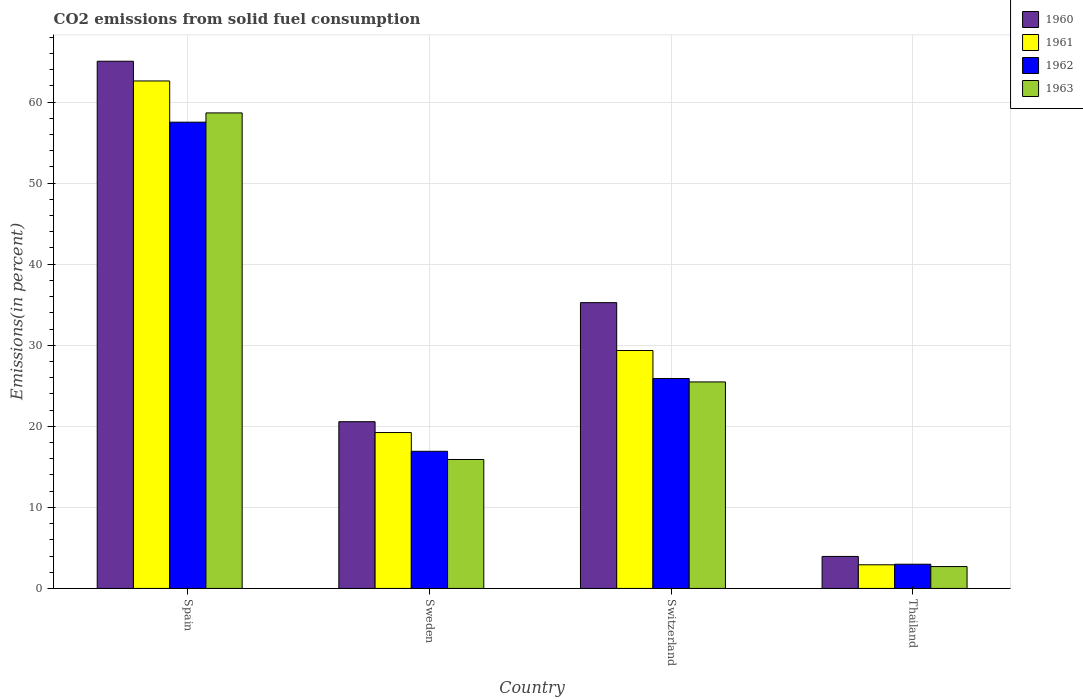How many groups of bars are there?
Provide a succinct answer. 4. How many bars are there on the 1st tick from the left?
Ensure brevity in your answer.  4. How many bars are there on the 3rd tick from the right?
Offer a very short reply. 4. What is the label of the 2nd group of bars from the left?
Keep it short and to the point. Sweden. In how many cases, is the number of bars for a given country not equal to the number of legend labels?
Your answer should be compact. 0. What is the total CO2 emitted in 1963 in Sweden?
Offer a very short reply. 15.91. Across all countries, what is the maximum total CO2 emitted in 1963?
Make the answer very short. 58.66. Across all countries, what is the minimum total CO2 emitted in 1961?
Your answer should be very brief. 2.92. In which country was the total CO2 emitted in 1961 maximum?
Your answer should be very brief. Spain. In which country was the total CO2 emitted in 1960 minimum?
Keep it short and to the point. Thailand. What is the total total CO2 emitted in 1960 in the graph?
Your answer should be very brief. 124.81. What is the difference between the total CO2 emitted in 1962 in Sweden and that in Switzerland?
Keep it short and to the point. -8.98. What is the difference between the total CO2 emitted in 1960 in Switzerland and the total CO2 emitted in 1961 in Thailand?
Give a very brief answer. 32.34. What is the average total CO2 emitted in 1963 per country?
Your answer should be compact. 25.69. What is the difference between the total CO2 emitted of/in 1960 and total CO2 emitted of/in 1963 in Sweden?
Give a very brief answer. 4.66. In how many countries, is the total CO2 emitted in 1962 greater than 34 %?
Your response must be concise. 1. What is the ratio of the total CO2 emitted in 1961 in Sweden to that in Thailand?
Offer a very short reply. 6.59. What is the difference between the highest and the second highest total CO2 emitted in 1960?
Give a very brief answer. 29.78. What is the difference between the highest and the lowest total CO2 emitted in 1960?
Offer a terse response. 61.09. Is it the case that in every country, the sum of the total CO2 emitted in 1961 and total CO2 emitted in 1963 is greater than the total CO2 emitted in 1962?
Provide a short and direct response. Yes. How many bars are there?
Make the answer very short. 16. Are the values on the major ticks of Y-axis written in scientific E-notation?
Your answer should be compact. No. Does the graph contain grids?
Ensure brevity in your answer.  Yes. Where does the legend appear in the graph?
Your answer should be very brief. Top right. How many legend labels are there?
Offer a terse response. 4. How are the legend labels stacked?
Your response must be concise. Vertical. What is the title of the graph?
Your answer should be compact. CO2 emissions from solid fuel consumption. Does "1980" appear as one of the legend labels in the graph?
Provide a succinct answer. No. What is the label or title of the X-axis?
Provide a short and direct response. Country. What is the label or title of the Y-axis?
Offer a terse response. Emissions(in percent). What is the Emissions(in percent) in 1960 in Spain?
Offer a terse response. 65.04. What is the Emissions(in percent) in 1961 in Spain?
Offer a very short reply. 62.6. What is the Emissions(in percent) of 1962 in Spain?
Your response must be concise. 57.52. What is the Emissions(in percent) of 1963 in Spain?
Keep it short and to the point. 58.66. What is the Emissions(in percent) of 1960 in Sweden?
Offer a very short reply. 20.57. What is the Emissions(in percent) in 1961 in Sweden?
Your answer should be very brief. 19.23. What is the Emissions(in percent) of 1962 in Sweden?
Make the answer very short. 16.92. What is the Emissions(in percent) of 1963 in Sweden?
Your answer should be very brief. 15.91. What is the Emissions(in percent) of 1960 in Switzerland?
Give a very brief answer. 35.26. What is the Emissions(in percent) of 1961 in Switzerland?
Provide a short and direct response. 29.35. What is the Emissions(in percent) in 1962 in Switzerland?
Provide a short and direct response. 25.9. What is the Emissions(in percent) in 1963 in Switzerland?
Provide a succinct answer. 25.48. What is the Emissions(in percent) in 1960 in Thailand?
Ensure brevity in your answer.  3.95. What is the Emissions(in percent) in 1961 in Thailand?
Offer a terse response. 2.92. What is the Emissions(in percent) of 1962 in Thailand?
Offer a terse response. 2.99. What is the Emissions(in percent) of 1963 in Thailand?
Your answer should be compact. 2.7. Across all countries, what is the maximum Emissions(in percent) of 1960?
Provide a short and direct response. 65.04. Across all countries, what is the maximum Emissions(in percent) in 1961?
Your response must be concise. 62.6. Across all countries, what is the maximum Emissions(in percent) in 1962?
Your response must be concise. 57.52. Across all countries, what is the maximum Emissions(in percent) in 1963?
Make the answer very short. 58.66. Across all countries, what is the minimum Emissions(in percent) in 1960?
Your answer should be very brief. 3.95. Across all countries, what is the minimum Emissions(in percent) of 1961?
Offer a very short reply. 2.92. Across all countries, what is the minimum Emissions(in percent) in 1962?
Offer a very short reply. 2.99. Across all countries, what is the minimum Emissions(in percent) in 1963?
Your answer should be compact. 2.7. What is the total Emissions(in percent) in 1960 in the graph?
Offer a terse response. 124.81. What is the total Emissions(in percent) in 1961 in the graph?
Your answer should be compact. 114.11. What is the total Emissions(in percent) of 1962 in the graph?
Offer a terse response. 103.32. What is the total Emissions(in percent) of 1963 in the graph?
Offer a very short reply. 102.74. What is the difference between the Emissions(in percent) of 1960 in Spain and that in Sweden?
Offer a terse response. 44.47. What is the difference between the Emissions(in percent) in 1961 in Spain and that in Sweden?
Make the answer very short. 43.37. What is the difference between the Emissions(in percent) in 1962 in Spain and that in Sweden?
Make the answer very short. 40.6. What is the difference between the Emissions(in percent) of 1963 in Spain and that in Sweden?
Keep it short and to the point. 42.75. What is the difference between the Emissions(in percent) of 1960 in Spain and that in Switzerland?
Offer a terse response. 29.78. What is the difference between the Emissions(in percent) of 1961 in Spain and that in Switzerland?
Your answer should be compact. 33.25. What is the difference between the Emissions(in percent) in 1962 in Spain and that in Switzerland?
Ensure brevity in your answer.  31.62. What is the difference between the Emissions(in percent) in 1963 in Spain and that in Switzerland?
Your answer should be very brief. 33.19. What is the difference between the Emissions(in percent) of 1960 in Spain and that in Thailand?
Your response must be concise. 61.09. What is the difference between the Emissions(in percent) in 1961 in Spain and that in Thailand?
Keep it short and to the point. 59.69. What is the difference between the Emissions(in percent) of 1962 in Spain and that in Thailand?
Offer a terse response. 54.53. What is the difference between the Emissions(in percent) of 1963 in Spain and that in Thailand?
Ensure brevity in your answer.  55.96. What is the difference between the Emissions(in percent) in 1960 in Sweden and that in Switzerland?
Offer a very short reply. -14.69. What is the difference between the Emissions(in percent) in 1961 in Sweden and that in Switzerland?
Ensure brevity in your answer.  -10.12. What is the difference between the Emissions(in percent) of 1962 in Sweden and that in Switzerland?
Ensure brevity in your answer.  -8.98. What is the difference between the Emissions(in percent) of 1963 in Sweden and that in Switzerland?
Provide a succinct answer. -9.57. What is the difference between the Emissions(in percent) in 1960 in Sweden and that in Thailand?
Your response must be concise. 16.62. What is the difference between the Emissions(in percent) in 1961 in Sweden and that in Thailand?
Ensure brevity in your answer.  16.31. What is the difference between the Emissions(in percent) in 1962 in Sweden and that in Thailand?
Provide a succinct answer. 13.93. What is the difference between the Emissions(in percent) of 1963 in Sweden and that in Thailand?
Your answer should be compact. 13.21. What is the difference between the Emissions(in percent) of 1960 in Switzerland and that in Thailand?
Give a very brief answer. 31.31. What is the difference between the Emissions(in percent) in 1961 in Switzerland and that in Thailand?
Your answer should be very brief. 26.43. What is the difference between the Emissions(in percent) in 1962 in Switzerland and that in Thailand?
Your answer should be compact. 22.91. What is the difference between the Emissions(in percent) of 1963 in Switzerland and that in Thailand?
Provide a short and direct response. 22.78. What is the difference between the Emissions(in percent) of 1960 in Spain and the Emissions(in percent) of 1961 in Sweden?
Offer a very short reply. 45.81. What is the difference between the Emissions(in percent) in 1960 in Spain and the Emissions(in percent) in 1962 in Sweden?
Offer a very short reply. 48.12. What is the difference between the Emissions(in percent) in 1960 in Spain and the Emissions(in percent) in 1963 in Sweden?
Provide a succinct answer. 49.13. What is the difference between the Emissions(in percent) of 1961 in Spain and the Emissions(in percent) of 1962 in Sweden?
Offer a terse response. 45.69. What is the difference between the Emissions(in percent) in 1961 in Spain and the Emissions(in percent) in 1963 in Sweden?
Ensure brevity in your answer.  46.7. What is the difference between the Emissions(in percent) of 1962 in Spain and the Emissions(in percent) of 1963 in Sweden?
Give a very brief answer. 41.61. What is the difference between the Emissions(in percent) of 1960 in Spain and the Emissions(in percent) of 1961 in Switzerland?
Your answer should be very brief. 35.69. What is the difference between the Emissions(in percent) of 1960 in Spain and the Emissions(in percent) of 1962 in Switzerland?
Offer a very short reply. 39.14. What is the difference between the Emissions(in percent) of 1960 in Spain and the Emissions(in percent) of 1963 in Switzerland?
Your answer should be compact. 39.56. What is the difference between the Emissions(in percent) of 1961 in Spain and the Emissions(in percent) of 1962 in Switzerland?
Your response must be concise. 36.7. What is the difference between the Emissions(in percent) in 1961 in Spain and the Emissions(in percent) in 1963 in Switzerland?
Make the answer very short. 37.13. What is the difference between the Emissions(in percent) in 1962 in Spain and the Emissions(in percent) in 1963 in Switzerland?
Provide a short and direct response. 32.04. What is the difference between the Emissions(in percent) in 1960 in Spain and the Emissions(in percent) in 1961 in Thailand?
Provide a succinct answer. 62.12. What is the difference between the Emissions(in percent) of 1960 in Spain and the Emissions(in percent) of 1962 in Thailand?
Make the answer very short. 62.05. What is the difference between the Emissions(in percent) of 1960 in Spain and the Emissions(in percent) of 1963 in Thailand?
Your response must be concise. 62.34. What is the difference between the Emissions(in percent) of 1961 in Spain and the Emissions(in percent) of 1962 in Thailand?
Offer a very short reply. 59.62. What is the difference between the Emissions(in percent) in 1961 in Spain and the Emissions(in percent) in 1963 in Thailand?
Make the answer very short. 59.91. What is the difference between the Emissions(in percent) of 1962 in Spain and the Emissions(in percent) of 1963 in Thailand?
Give a very brief answer. 54.82. What is the difference between the Emissions(in percent) in 1960 in Sweden and the Emissions(in percent) in 1961 in Switzerland?
Provide a short and direct response. -8.78. What is the difference between the Emissions(in percent) in 1960 in Sweden and the Emissions(in percent) in 1962 in Switzerland?
Make the answer very short. -5.33. What is the difference between the Emissions(in percent) in 1960 in Sweden and the Emissions(in percent) in 1963 in Switzerland?
Keep it short and to the point. -4.91. What is the difference between the Emissions(in percent) in 1961 in Sweden and the Emissions(in percent) in 1962 in Switzerland?
Give a very brief answer. -6.67. What is the difference between the Emissions(in percent) in 1961 in Sweden and the Emissions(in percent) in 1963 in Switzerland?
Ensure brevity in your answer.  -6.24. What is the difference between the Emissions(in percent) in 1962 in Sweden and the Emissions(in percent) in 1963 in Switzerland?
Provide a succinct answer. -8.56. What is the difference between the Emissions(in percent) in 1960 in Sweden and the Emissions(in percent) in 1961 in Thailand?
Offer a terse response. 17.65. What is the difference between the Emissions(in percent) of 1960 in Sweden and the Emissions(in percent) of 1962 in Thailand?
Provide a succinct answer. 17.58. What is the difference between the Emissions(in percent) in 1960 in Sweden and the Emissions(in percent) in 1963 in Thailand?
Give a very brief answer. 17.87. What is the difference between the Emissions(in percent) in 1961 in Sweden and the Emissions(in percent) in 1962 in Thailand?
Offer a terse response. 16.25. What is the difference between the Emissions(in percent) of 1961 in Sweden and the Emissions(in percent) of 1963 in Thailand?
Give a very brief answer. 16.53. What is the difference between the Emissions(in percent) of 1962 in Sweden and the Emissions(in percent) of 1963 in Thailand?
Your answer should be very brief. 14.22. What is the difference between the Emissions(in percent) of 1960 in Switzerland and the Emissions(in percent) of 1961 in Thailand?
Give a very brief answer. 32.34. What is the difference between the Emissions(in percent) of 1960 in Switzerland and the Emissions(in percent) of 1962 in Thailand?
Keep it short and to the point. 32.27. What is the difference between the Emissions(in percent) in 1960 in Switzerland and the Emissions(in percent) in 1963 in Thailand?
Provide a succinct answer. 32.56. What is the difference between the Emissions(in percent) of 1961 in Switzerland and the Emissions(in percent) of 1962 in Thailand?
Provide a succinct answer. 26.37. What is the difference between the Emissions(in percent) of 1961 in Switzerland and the Emissions(in percent) of 1963 in Thailand?
Offer a terse response. 26.65. What is the difference between the Emissions(in percent) of 1962 in Switzerland and the Emissions(in percent) of 1963 in Thailand?
Offer a very short reply. 23.2. What is the average Emissions(in percent) in 1960 per country?
Ensure brevity in your answer.  31.2. What is the average Emissions(in percent) in 1961 per country?
Your answer should be compact. 28.53. What is the average Emissions(in percent) of 1962 per country?
Your answer should be very brief. 25.83. What is the average Emissions(in percent) in 1963 per country?
Your answer should be very brief. 25.69. What is the difference between the Emissions(in percent) in 1960 and Emissions(in percent) in 1961 in Spain?
Provide a short and direct response. 2.43. What is the difference between the Emissions(in percent) in 1960 and Emissions(in percent) in 1962 in Spain?
Make the answer very short. 7.52. What is the difference between the Emissions(in percent) of 1960 and Emissions(in percent) of 1963 in Spain?
Your response must be concise. 6.38. What is the difference between the Emissions(in percent) of 1961 and Emissions(in percent) of 1962 in Spain?
Offer a terse response. 5.08. What is the difference between the Emissions(in percent) of 1961 and Emissions(in percent) of 1963 in Spain?
Your answer should be very brief. 3.94. What is the difference between the Emissions(in percent) of 1962 and Emissions(in percent) of 1963 in Spain?
Give a very brief answer. -1.14. What is the difference between the Emissions(in percent) of 1960 and Emissions(in percent) of 1961 in Sweden?
Give a very brief answer. 1.34. What is the difference between the Emissions(in percent) in 1960 and Emissions(in percent) in 1962 in Sweden?
Your response must be concise. 3.65. What is the difference between the Emissions(in percent) of 1960 and Emissions(in percent) of 1963 in Sweden?
Your response must be concise. 4.66. What is the difference between the Emissions(in percent) of 1961 and Emissions(in percent) of 1962 in Sweden?
Provide a short and direct response. 2.31. What is the difference between the Emissions(in percent) in 1961 and Emissions(in percent) in 1963 in Sweden?
Offer a terse response. 3.32. What is the difference between the Emissions(in percent) in 1962 and Emissions(in percent) in 1963 in Sweden?
Keep it short and to the point. 1.01. What is the difference between the Emissions(in percent) in 1960 and Emissions(in percent) in 1961 in Switzerland?
Provide a short and direct response. 5.9. What is the difference between the Emissions(in percent) in 1960 and Emissions(in percent) in 1962 in Switzerland?
Keep it short and to the point. 9.36. What is the difference between the Emissions(in percent) in 1960 and Emissions(in percent) in 1963 in Switzerland?
Offer a terse response. 9.78. What is the difference between the Emissions(in percent) in 1961 and Emissions(in percent) in 1962 in Switzerland?
Your answer should be compact. 3.45. What is the difference between the Emissions(in percent) in 1961 and Emissions(in percent) in 1963 in Switzerland?
Your answer should be very brief. 3.88. What is the difference between the Emissions(in percent) in 1962 and Emissions(in percent) in 1963 in Switzerland?
Your answer should be compact. 0.42. What is the difference between the Emissions(in percent) in 1960 and Emissions(in percent) in 1961 in Thailand?
Make the answer very short. 1.03. What is the difference between the Emissions(in percent) in 1960 and Emissions(in percent) in 1962 in Thailand?
Keep it short and to the point. 0.96. What is the difference between the Emissions(in percent) of 1960 and Emissions(in percent) of 1963 in Thailand?
Your answer should be very brief. 1.25. What is the difference between the Emissions(in percent) of 1961 and Emissions(in percent) of 1962 in Thailand?
Your answer should be compact. -0.07. What is the difference between the Emissions(in percent) in 1961 and Emissions(in percent) in 1963 in Thailand?
Offer a very short reply. 0.22. What is the difference between the Emissions(in percent) of 1962 and Emissions(in percent) of 1963 in Thailand?
Offer a terse response. 0.29. What is the ratio of the Emissions(in percent) of 1960 in Spain to that in Sweden?
Provide a succinct answer. 3.16. What is the ratio of the Emissions(in percent) of 1961 in Spain to that in Sweden?
Offer a terse response. 3.26. What is the ratio of the Emissions(in percent) of 1962 in Spain to that in Sweden?
Your response must be concise. 3.4. What is the ratio of the Emissions(in percent) in 1963 in Spain to that in Sweden?
Offer a terse response. 3.69. What is the ratio of the Emissions(in percent) of 1960 in Spain to that in Switzerland?
Your answer should be very brief. 1.84. What is the ratio of the Emissions(in percent) in 1961 in Spain to that in Switzerland?
Give a very brief answer. 2.13. What is the ratio of the Emissions(in percent) in 1962 in Spain to that in Switzerland?
Offer a terse response. 2.22. What is the ratio of the Emissions(in percent) in 1963 in Spain to that in Switzerland?
Your response must be concise. 2.3. What is the ratio of the Emissions(in percent) in 1960 in Spain to that in Thailand?
Make the answer very short. 16.47. What is the ratio of the Emissions(in percent) in 1961 in Spain to that in Thailand?
Give a very brief answer. 21.46. What is the ratio of the Emissions(in percent) of 1962 in Spain to that in Thailand?
Give a very brief answer. 19.26. What is the ratio of the Emissions(in percent) in 1963 in Spain to that in Thailand?
Offer a very short reply. 21.73. What is the ratio of the Emissions(in percent) of 1960 in Sweden to that in Switzerland?
Keep it short and to the point. 0.58. What is the ratio of the Emissions(in percent) in 1961 in Sweden to that in Switzerland?
Your answer should be very brief. 0.66. What is the ratio of the Emissions(in percent) in 1962 in Sweden to that in Switzerland?
Your answer should be compact. 0.65. What is the ratio of the Emissions(in percent) in 1963 in Sweden to that in Switzerland?
Offer a terse response. 0.62. What is the ratio of the Emissions(in percent) in 1960 in Sweden to that in Thailand?
Give a very brief answer. 5.21. What is the ratio of the Emissions(in percent) in 1961 in Sweden to that in Thailand?
Offer a very short reply. 6.59. What is the ratio of the Emissions(in percent) in 1962 in Sweden to that in Thailand?
Provide a short and direct response. 5.67. What is the ratio of the Emissions(in percent) in 1963 in Sweden to that in Thailand?
Offer a terse response. 5.89. What is the ratio of the Emissions(in percent) in 1960 in Switzerland to that in Thailand?
Your answer should be very brief. 8.93. What is the ratio of the Emissions(in percent) in 1961 in Switzerland to that in Thailand?
Offer a very short reply. 10.06. What is the ratio of the Emissions(in percent) in 1962 in Switzerland to that in Thailand?
Your response must be concise. 8.67. What is the ratio of the Emissions(in percent) in 1963 in Switzerland to that in Thailand?
Provide a succinct answer. 9.44. What is the difference between the highest and the second highest Emissions(in percent) in 1960?
Your response must be concise. 29.78. What is the difference between the highest and the second highest Emissions(in percent) in 1961?
Your answer should be very brief. 33.25. What is the difference between the highest and the second highest Emissions(in percent) in 1962?
Offer a terse response. 31.62. What is the difference between the highest and the second highest Emissions(in percent) of 1963?
Your answer should be compact. 33.19. What is the difference between the highest and the lowest Emissions(in percent) of 1960?
Make the answer very short. 61.09. What is the difference between the highest and the lowest Emissions(in percent) of 1961?
Your answer should be compact. 59.69. What is the difference between the highest and the lowest Emissions(in percent) of 1962?
Provide a succinct answer. 54.53. What is the difference between the highest and the lowest Emissions(in percent) in 1963?
Provide a short and direct response. 55.96. 